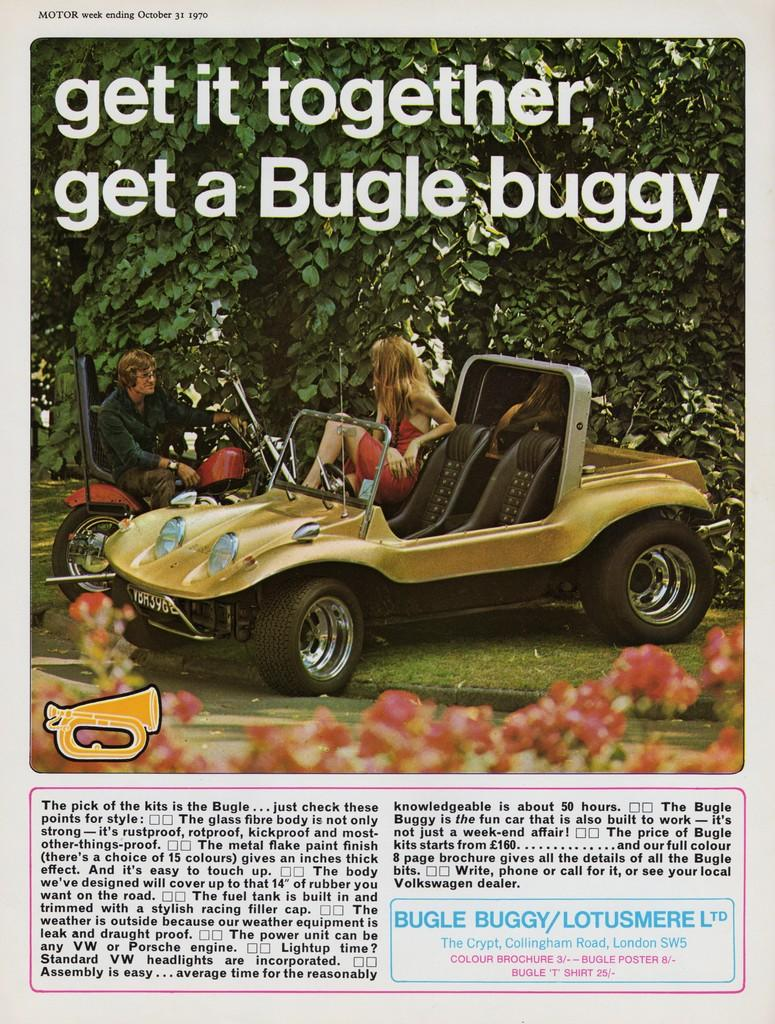What is written on the paper in the image? The facts do not specify the content of the text on the paper. What type of vegetation is present in the image? There are trees, flower plants, and grass in the image. What is the man and woman doing in the image? The facts do not specify the actions of the man and woman are performing. What type of vehicles are in the image? The facts do not specify the type of vehicles in the image. Can you see a frog holding a spoon in the image? No, there is no frog or spoon present in the image. What scientific discoveries are mentioned in the image? The facts do not mention any scientific content in the image. 